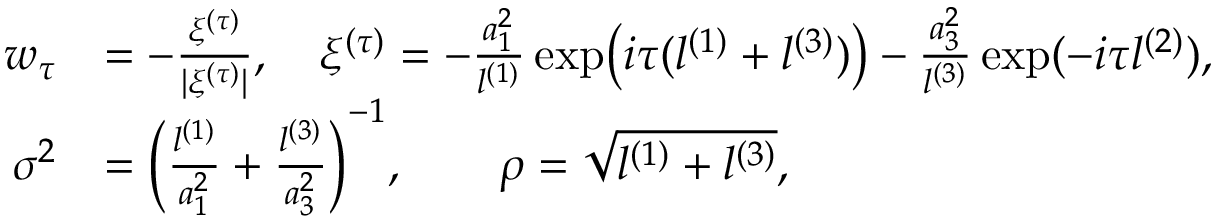Convert formula to latex. <formula><loc_0><loc_0><loc_500><loc_500>\begin{array} { r l } { w _ { \tau } } & { = - \frac { \xi ^ { ( \tau ) } } { | \xi ^ { ( \tau ) } | } , \quad \xi ^ { ( \tau ) } = - \frac { a _ { 1 } ^ { 2 } } { l ^ { ( 1 ) } } \exp \left ( i \tau ( l ^ { ( 1 ) } + l ^ { ( 3 ) } ) \right ) - \frac { a _ { 3 } ^ { 2 } } { l ^ { ( 3 ) } } \exp ( - i \tau l ^ { ( 2 ) } ) , } \\ { \sigma ^ { 2 } } & { = \left ( \frac { l ^ { ( 1 ) } } { a _ { 1 } ^ { 2 } } + \frac { l ^ { ( 3 ) } } { a _ { 3 } ^ { 2 } } \right ) ^ { - 1 } , \quad \rho = \sqrt { l ^ { ( 1 ) } + l ^ { ( 3 ) } } , } \end{array}</formula> 